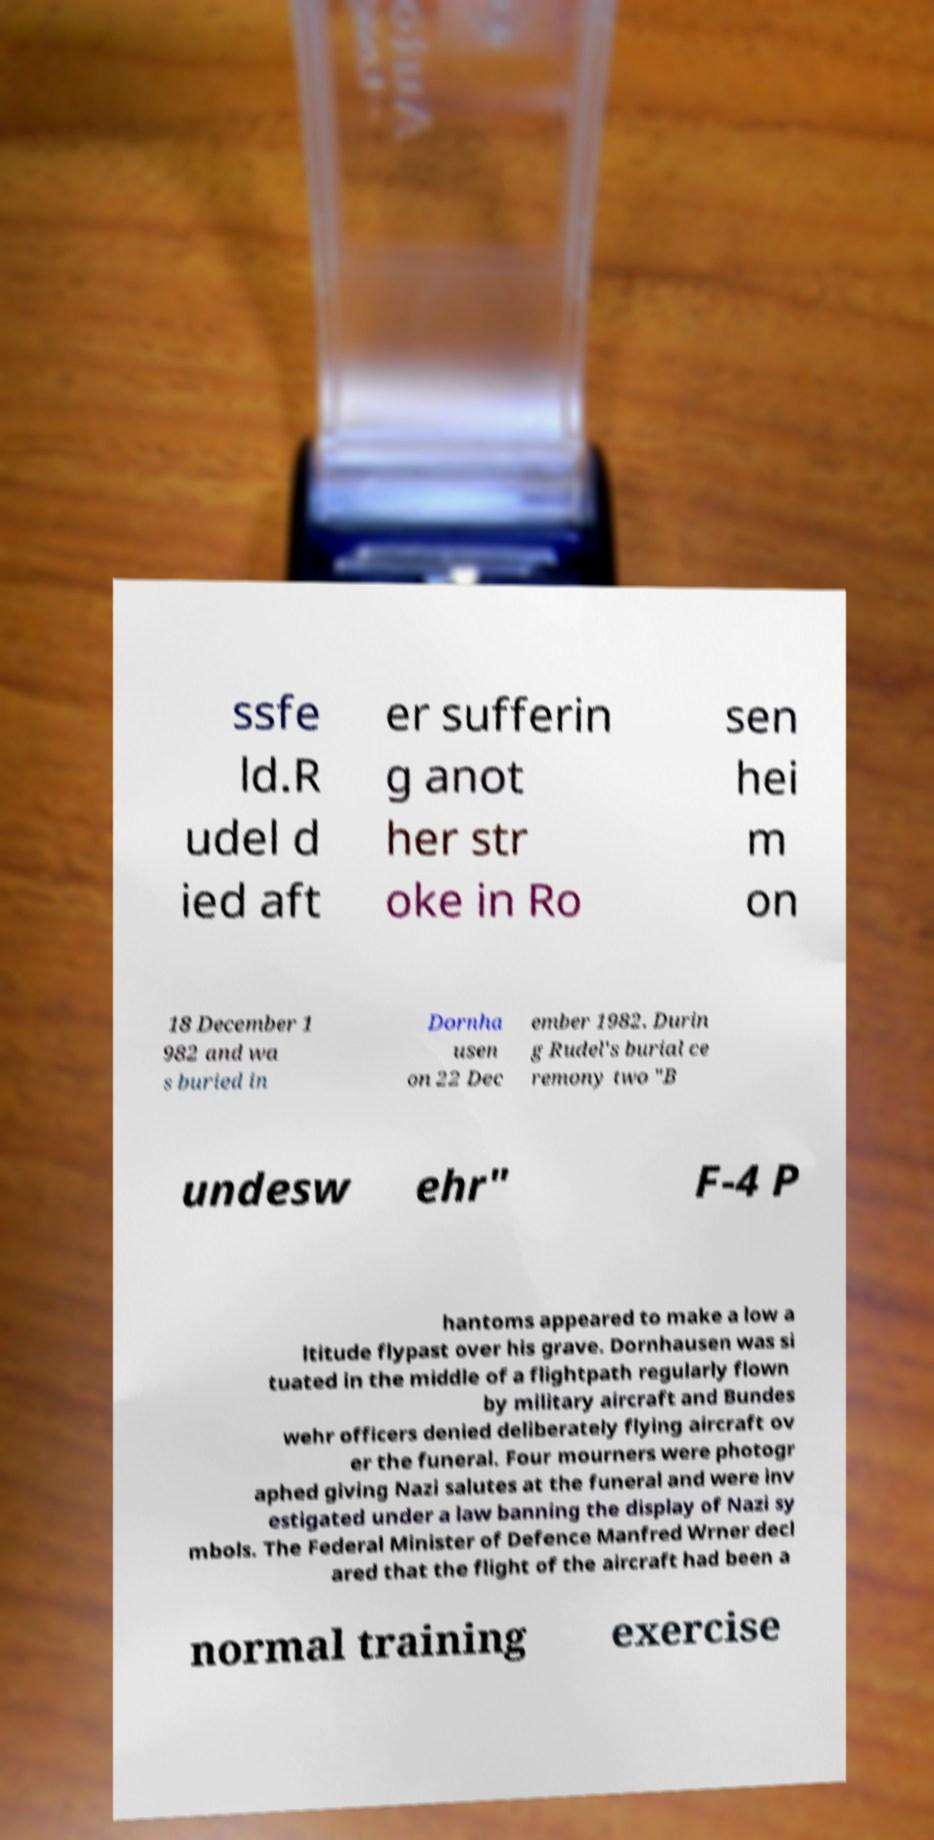I need the written content from this picture converted into text. Can you do that? ssfe ld.R udel d ied aft er sufferin g anot her str oke in Ro sen hei m on 18 December 1 982 and wa s buried in Dornha usen on 22 Dec ember 1982. Durin g Rudel's burial ce remony two "B undesw ehr" F-4 P hantoms appeared to make a low a ltitude flypast over his grave. Dornhausen was si tuated in the middle of a flightpath regularly flown by military aircraft and Bundes wehr officers denied deliberately flying aircraft ov er the funeral. Four mourners were photogr aphed giving Nazi salutes at the funeral and were inv estigated under a law banning the display of Nazi sy mbols. The Federal Minister of Defence Manfred Wrner decl ared that the flight of the aircraft had been a normal training exercise 